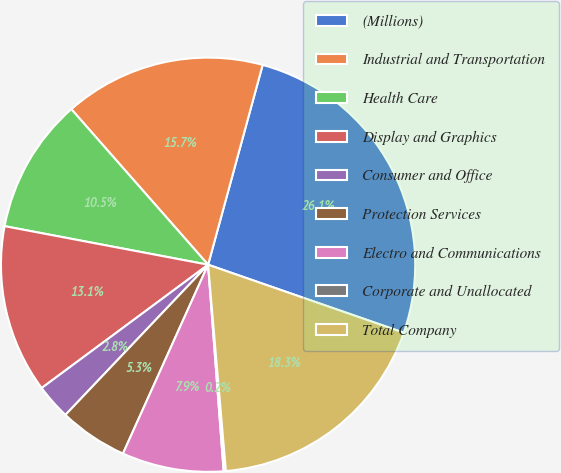<chart> <loc_0><loc_0><loc_500><loc_500><pie_chart><fcel>(Millions)<fcel>Industrial and Transportation<fcel>Health Care<fcel>Display and Graphics<fcel>Consumer and Office<fcel>Protection Services<fcel>Electro and Communications<fcel>Corporate and Unallocated<fcel>Total Company<nl><fcel>26.08%<fcel>15.72%<fcel>10.54%<fcel>13.13%<fcel>2.76%<fcel>5.35%<fcel>7.94%<fcel>0.17%<fcel>18.31%<nl></chart> 